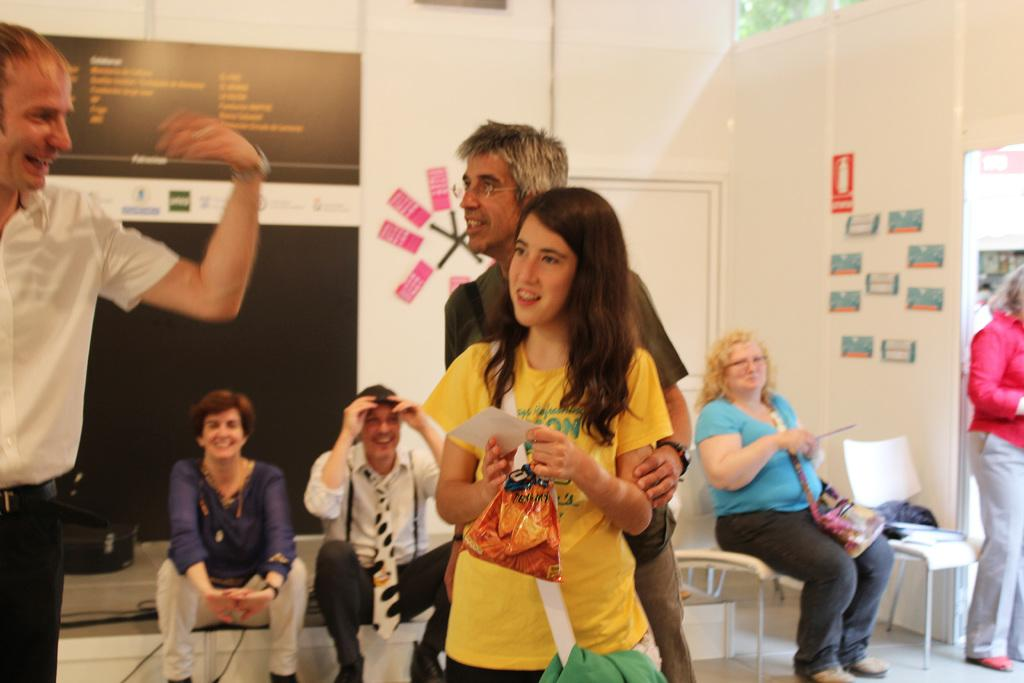How many people are in the image? There is a group of people in the image. What are some of the people in the image doing? Some people are sitting on chairs, while others are standing. What can be seen in the background of the image? There is a wall in the background of the image. What grade are the people teaching in the image? There is no indication in the image that the people are teaching, nor is there any information about their grade level. 